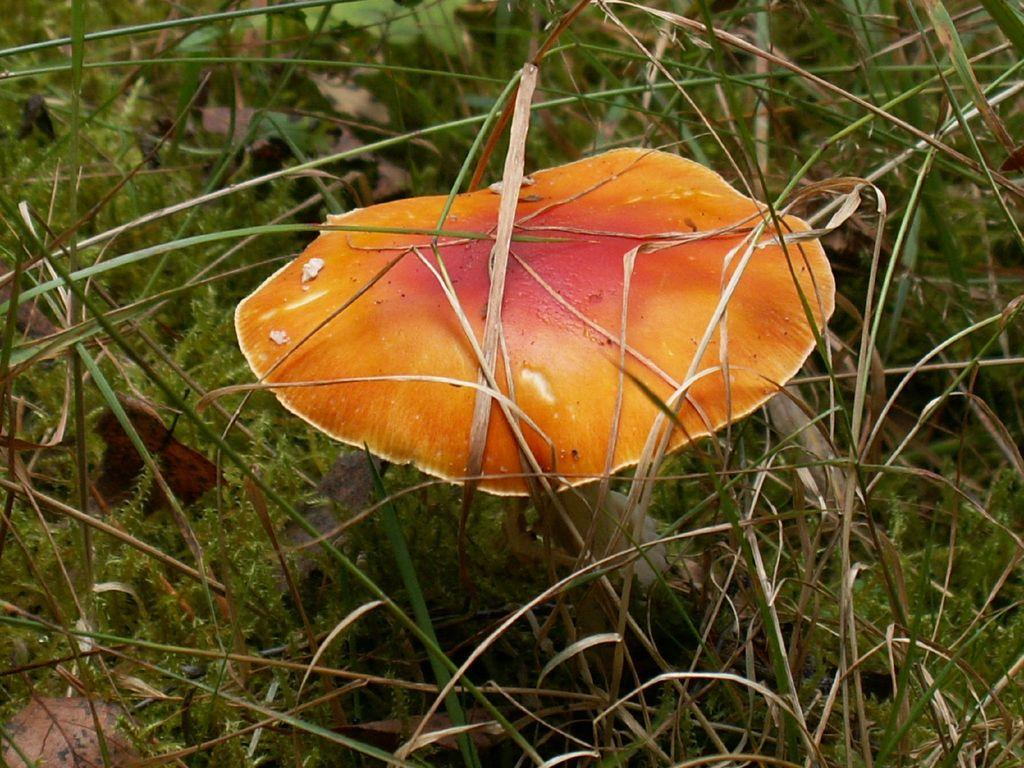What is the main subject of the image? The main subject of the image is a mushroom. Can you describe the color of the mushroom? The mushroom is orange in color. What type of vegetation is present in the image? There is green-colored grass in the image. Can you tell me how many silver trucks are parked next to the mushroom in the image? There are no silver trucks present in the image; it only features a mushroom and green-colored grass. 